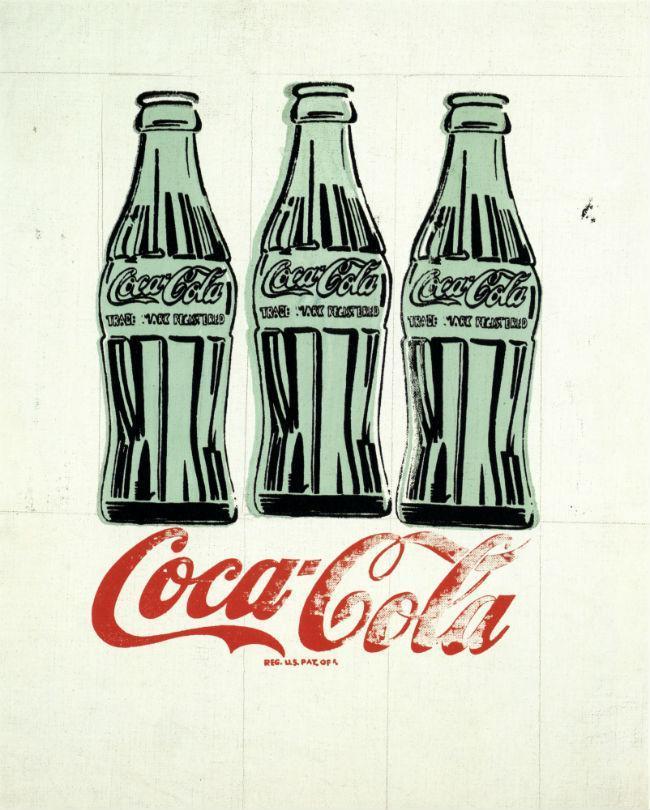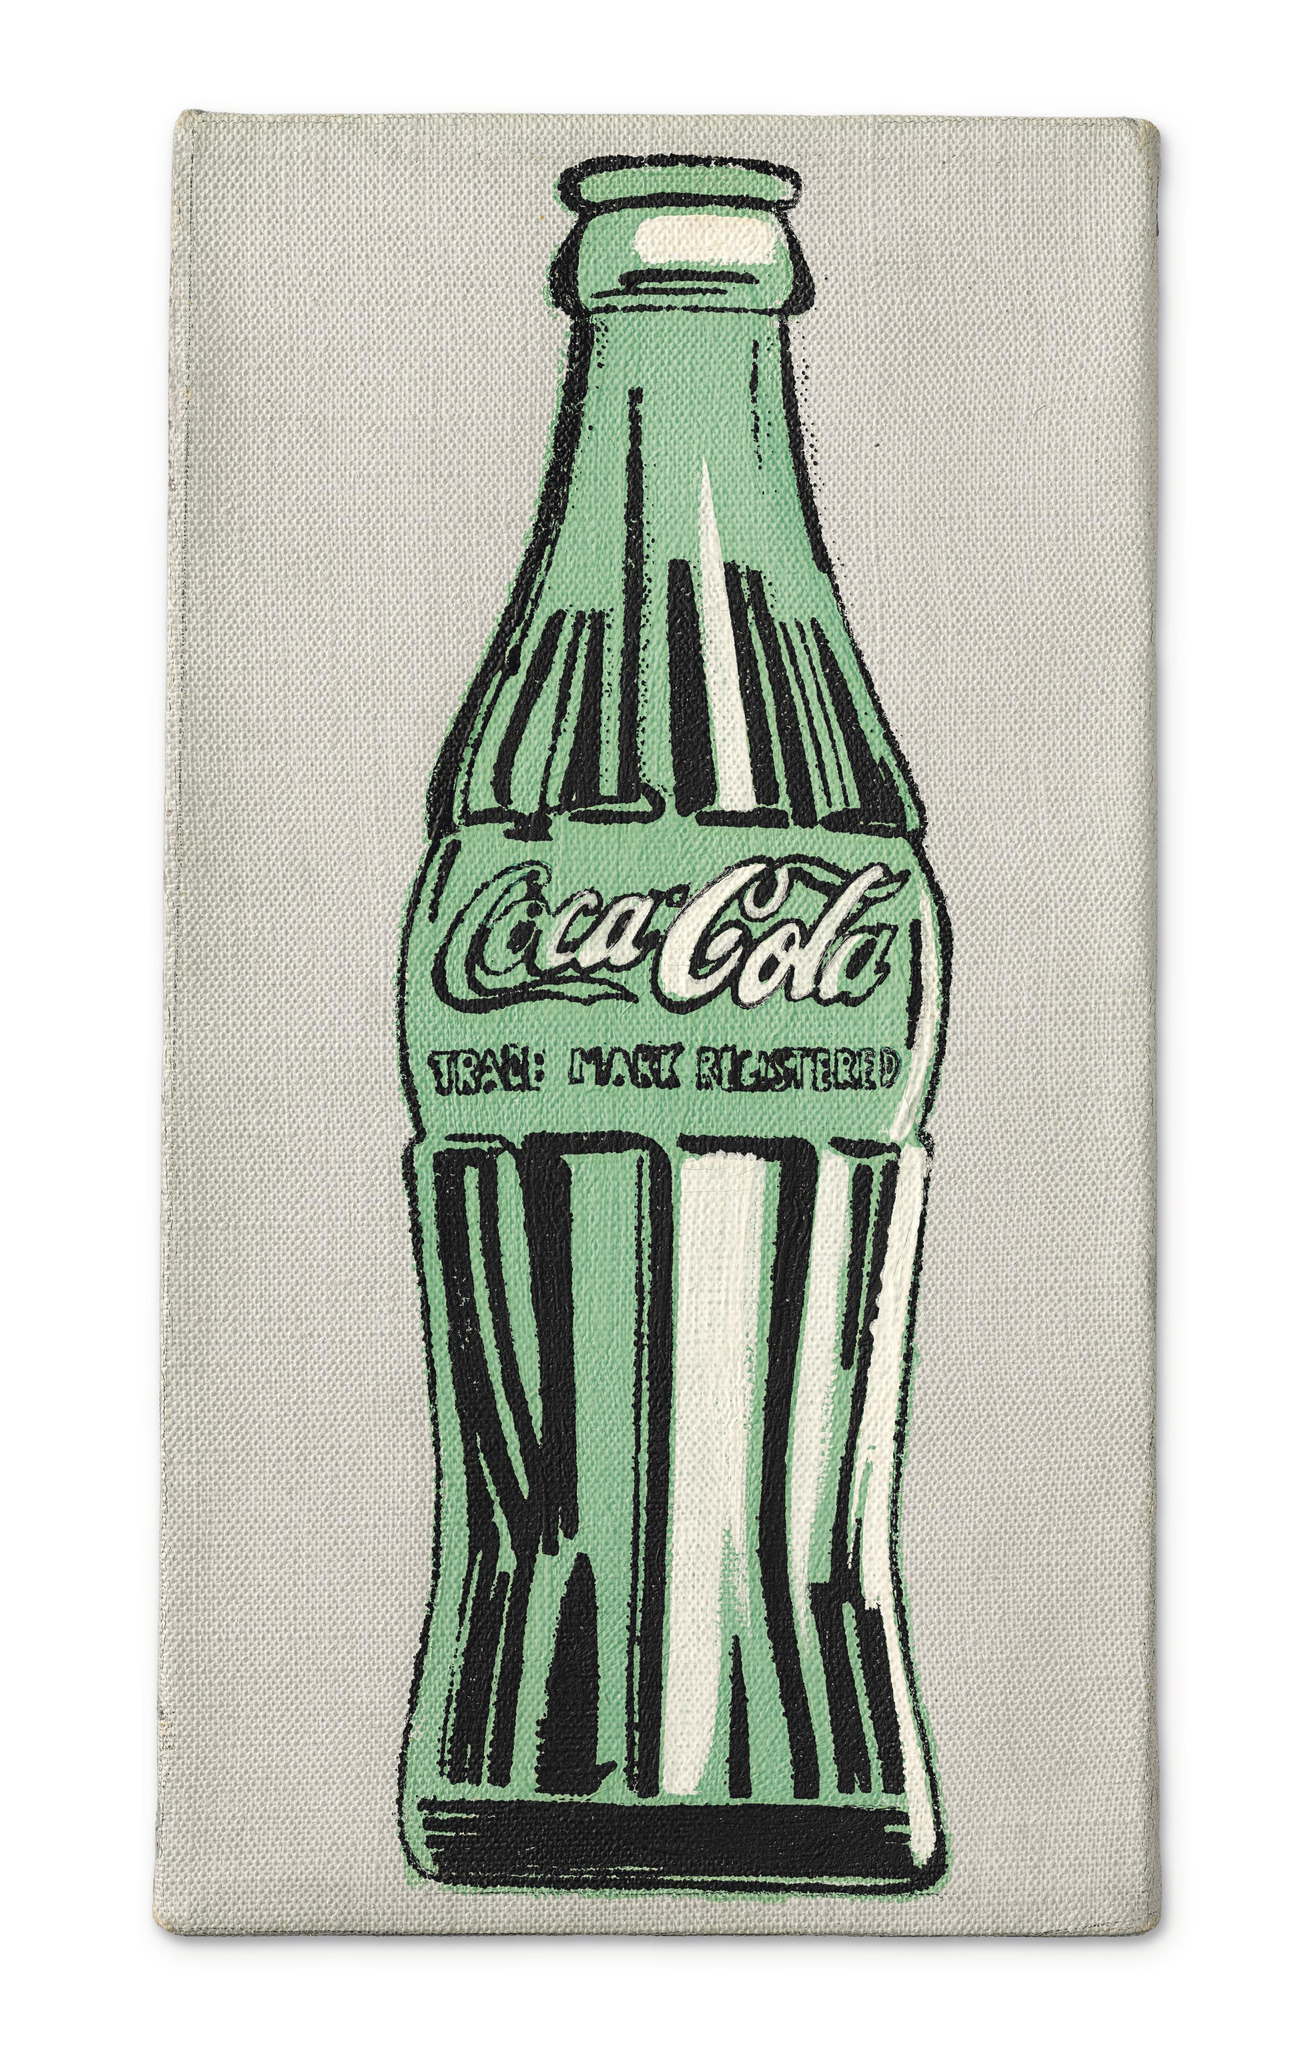The first image is the image on the left, the second image is the image on the right. Considering the images on both sides, is "There are four bottles of soda." valid? Answer yes or no. Yes. 